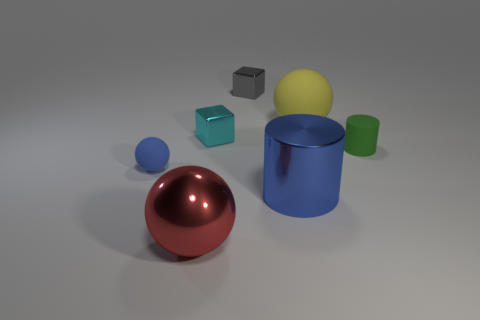Subtract all big spheres. How many spheres are left? 1 Subtract all red spheres. How many spheres are left? 2 Subtract all spheres. How many objects are left? 4 Subtract 2 spheres. How many spheres are left? 1 Add 6 yellow spheres. How many yellow spheres exist? 7 Add 2 cyan shiny cubes. How many objects exist? 9 Subtract 0 yellow blocks. How many objects are left? 7 Subtract all cyan cubes. Subtract all purple cylinders. How many cubes are left? 1 Subtract all purple balls. How many cyan cubes are left? 1 Subtract all matte things. Subtract all small blocks. How many objects are left? 2 